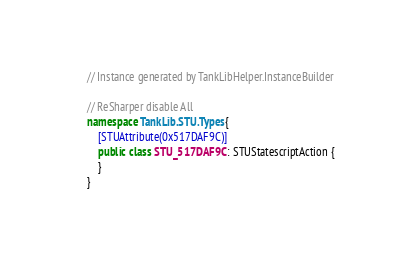Convert code to text. <code><loc_0><loc_0><loc_500><loc_500><_C#_>// Instance generated by TankLibHelper.InstanceBuilder

// ReSharper disable All
namespace TankLib.STU.Types {
    [STUAttribute(0x517DAF9C)]
    public class STU_517DAF9C : STUStatescriptAction {
    }
}
</code> 